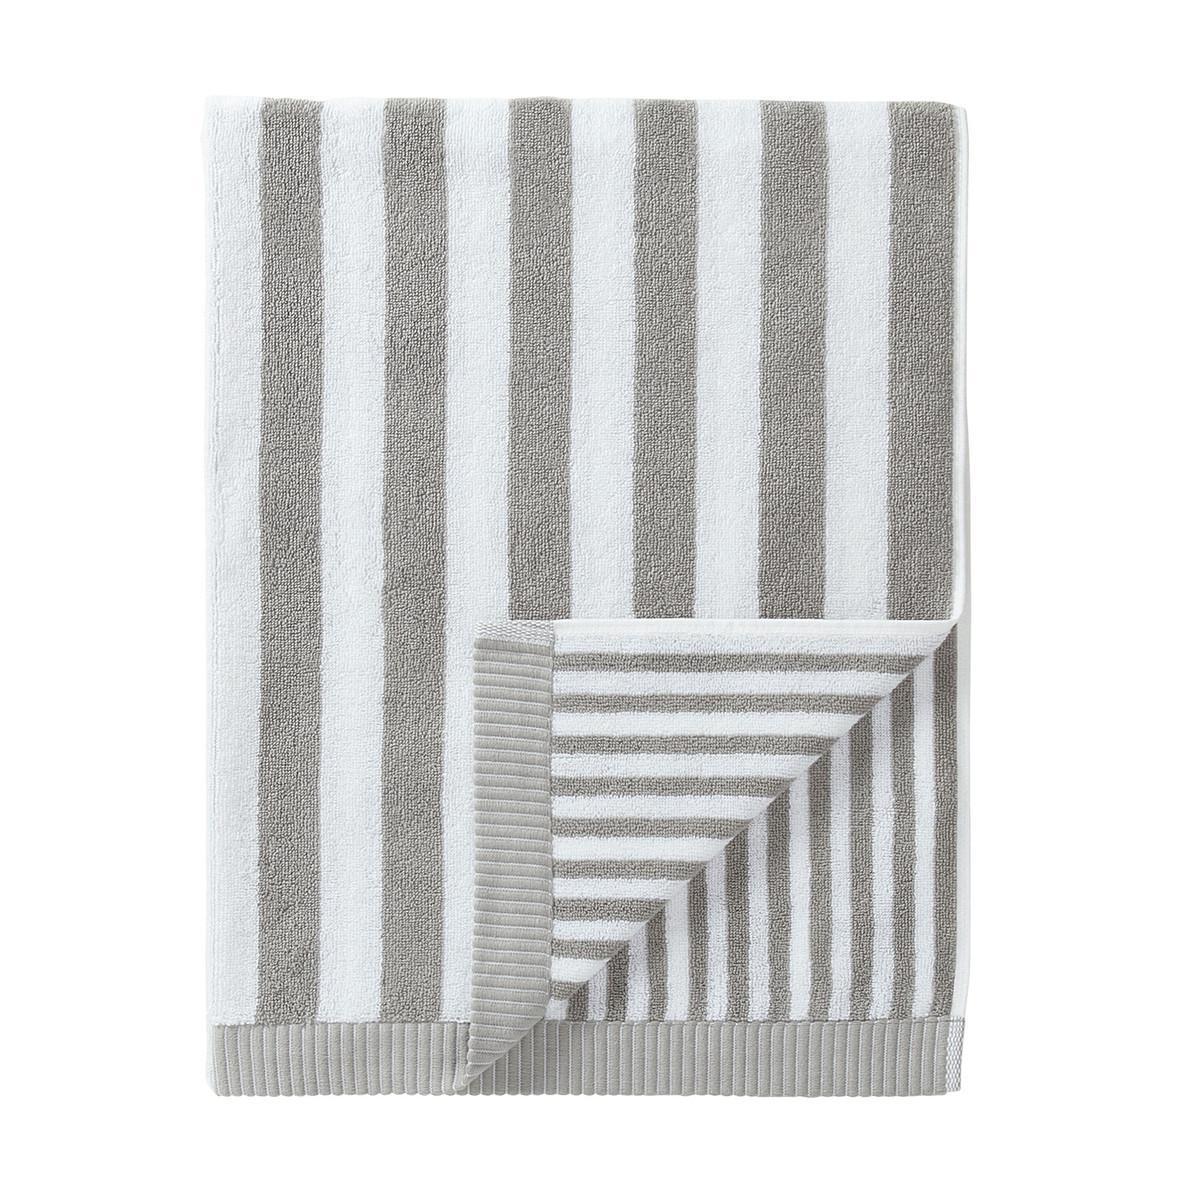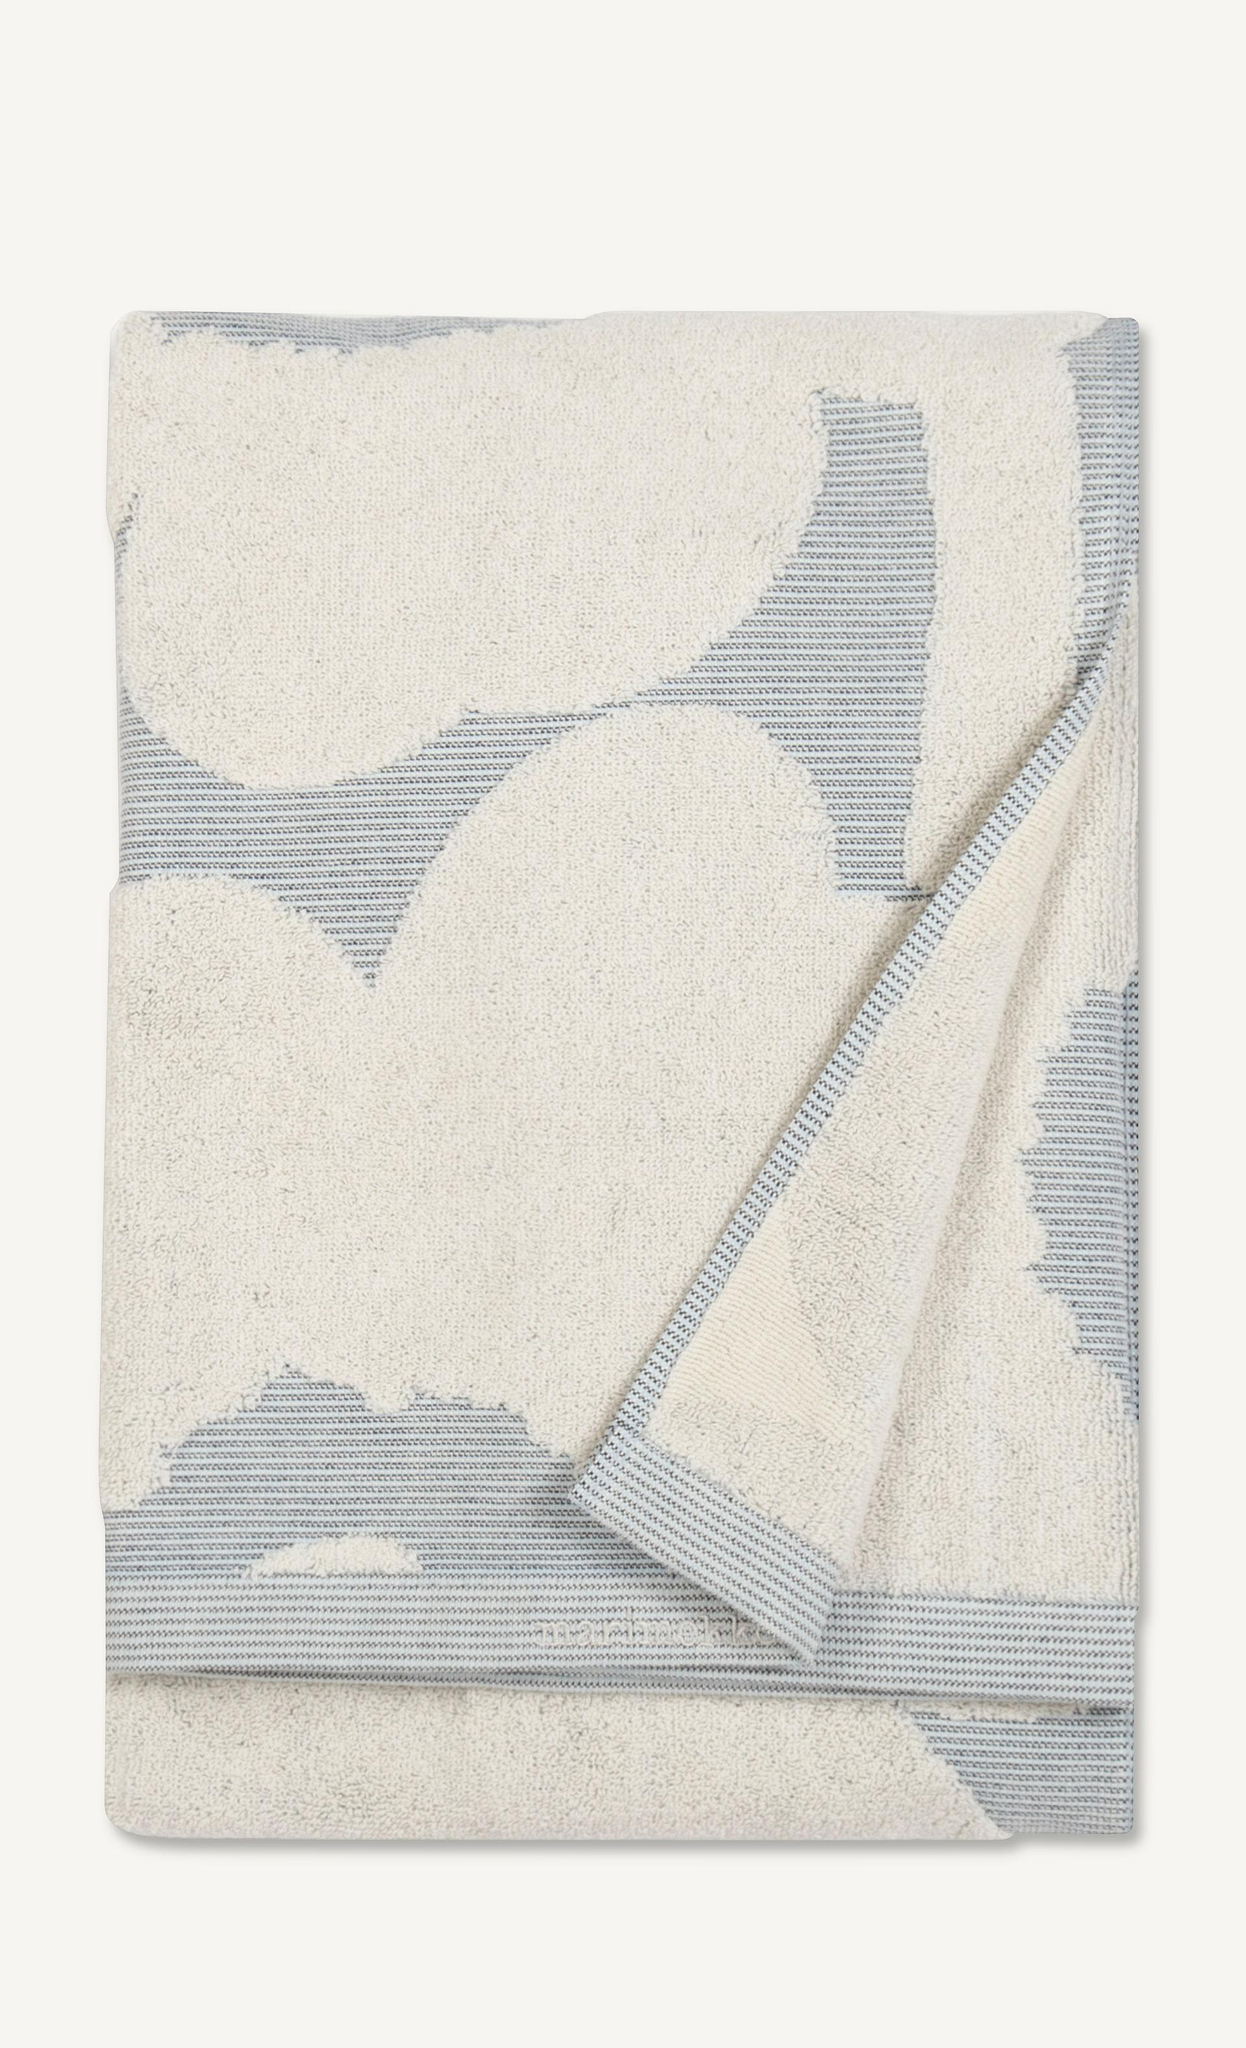The first image is the image on the left, the second image is the image on the right. Examine the images to the left and right. Is the description "Exactly one towel's bottom right corner is folded over." accurate? Answer yes or no. No. 